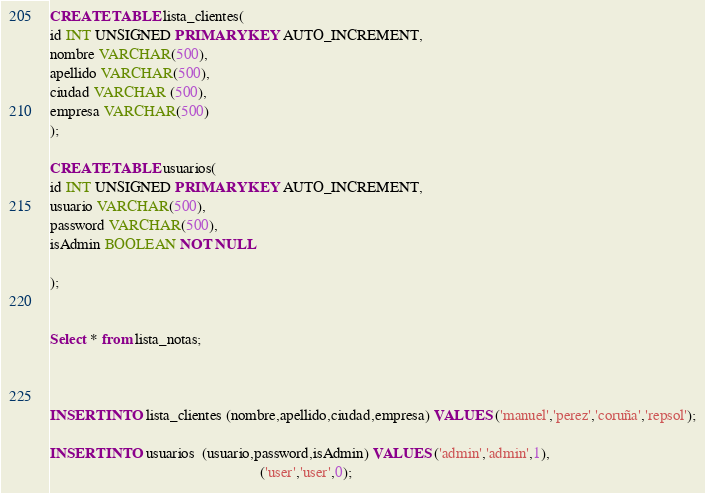Convert code to text. <code><loc_0><loc_0><loc_500><loc_500><_SQL_>CREATE TABLE lista_clientes(
id INT UNSIGNED PRIMARY KEY AUTO_INCREMENT,
nombre VARCHAR(500),
apellido VARCHAR(500),
ciudad VARCHAR (500),
empresa VARCHAR(500)
); 

CREATE TABLE usuarios(
id INT UNSIGNED PRIMARY KEY AUTO_INCREMENT,
usuario VARCHAR(500),
password VARCHAR(500),
isAdmin BOOLEAN NOT NULL

);


Select * from lista_notas;



INSERT INTO lista_clientes (nombre,apellido,ciudad,empresa) VALUES ('manuel','perez','coruña','repsol');

INSERT INTO usuarios  (usuario,password,isAdmin) VALUES ('admin','admin',1),
														('user','user',0);




</code> 